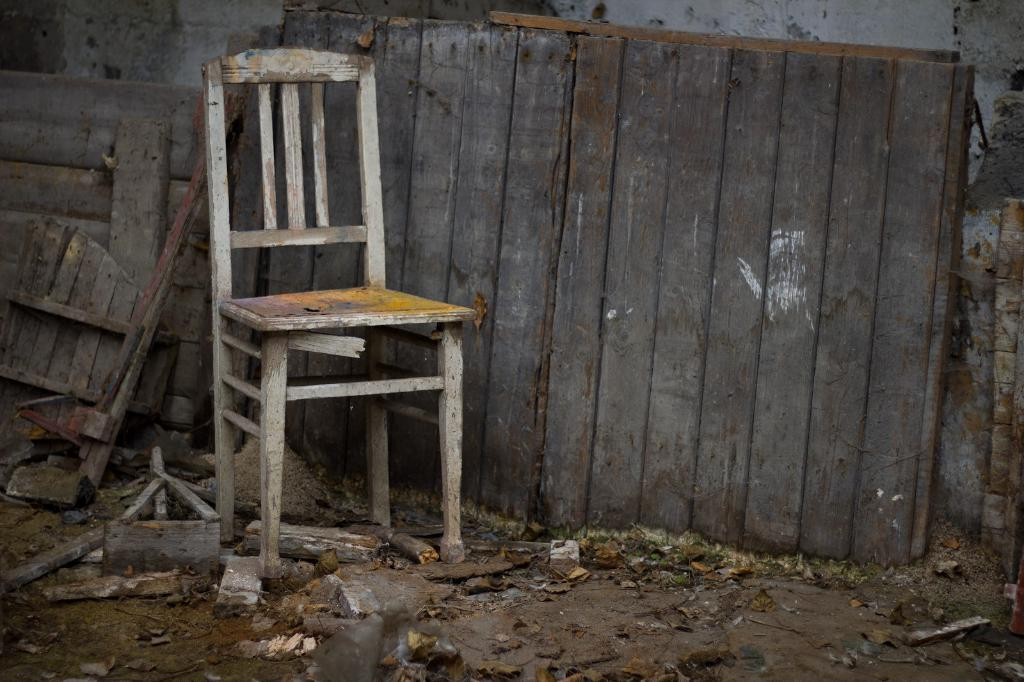What material is the chair made of in the image? The chair in the image is made of wood. What other wooden structure can be seen in the image? There is a wooden fence visible in the image. What is on the ground in the image? There are objects on the ground in the image. What type of noise can be heard coming from the chain in the image? There is no chain present in the image, so it is not possible to determine what type of noise might be heard. 